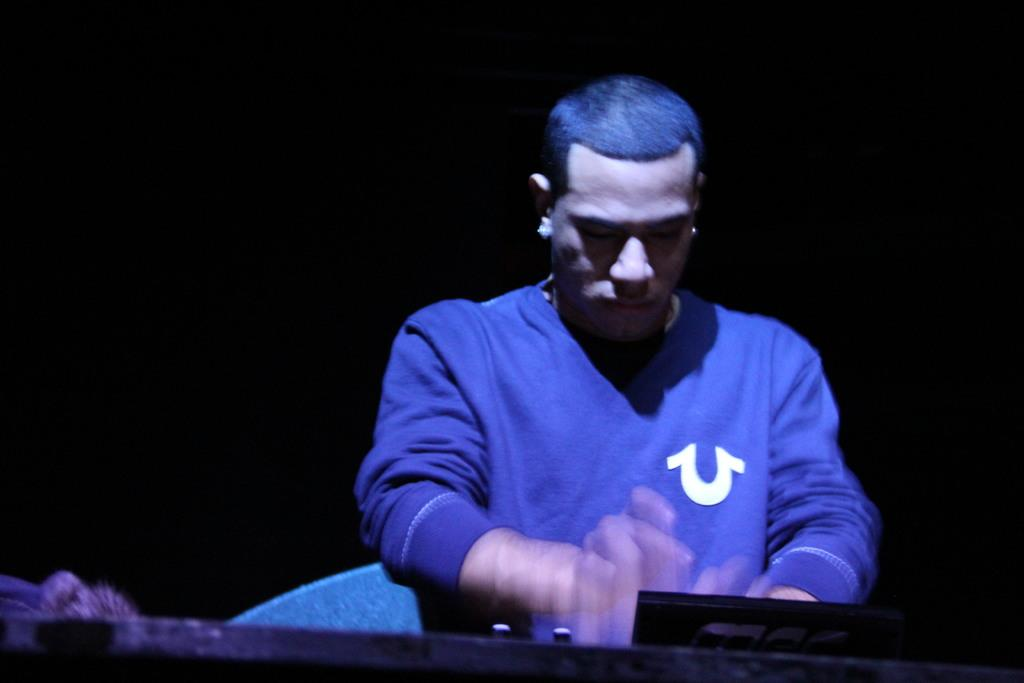Who is present in the image? There is a man in the image. What is the man wearing? The man is wearing a blue dress. What can be seen in front of the man? There is a black object in front of the man. How would you describe the lighting in the image? The image appears to be slightly dark. What type of sheet is covering the man in the image? There is no sheet covering the man in the image; he is wearing a blue dress. What kind of competition is the man participating in within the image? There is no competition depicted in the image; it only shows a man wearing a blue dress with a black object in front of him. 